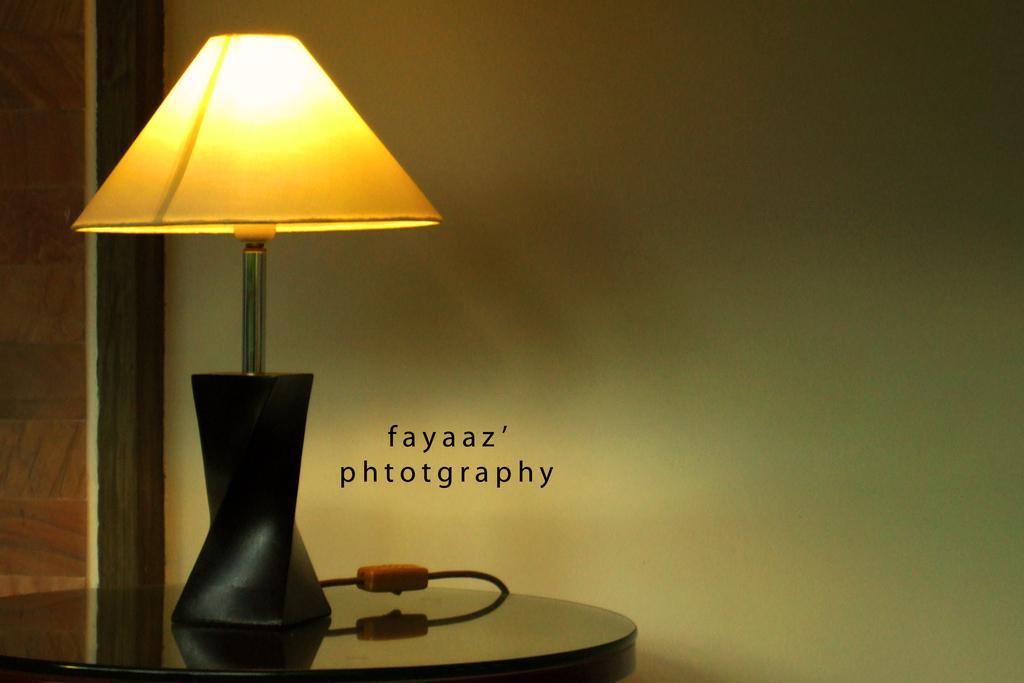Could you give a brief overview of what you see in this image? In this image there is a lamp on the table. Beside the lamp there is some text. In the background there is a wall. The lamp is connected with the wire. 